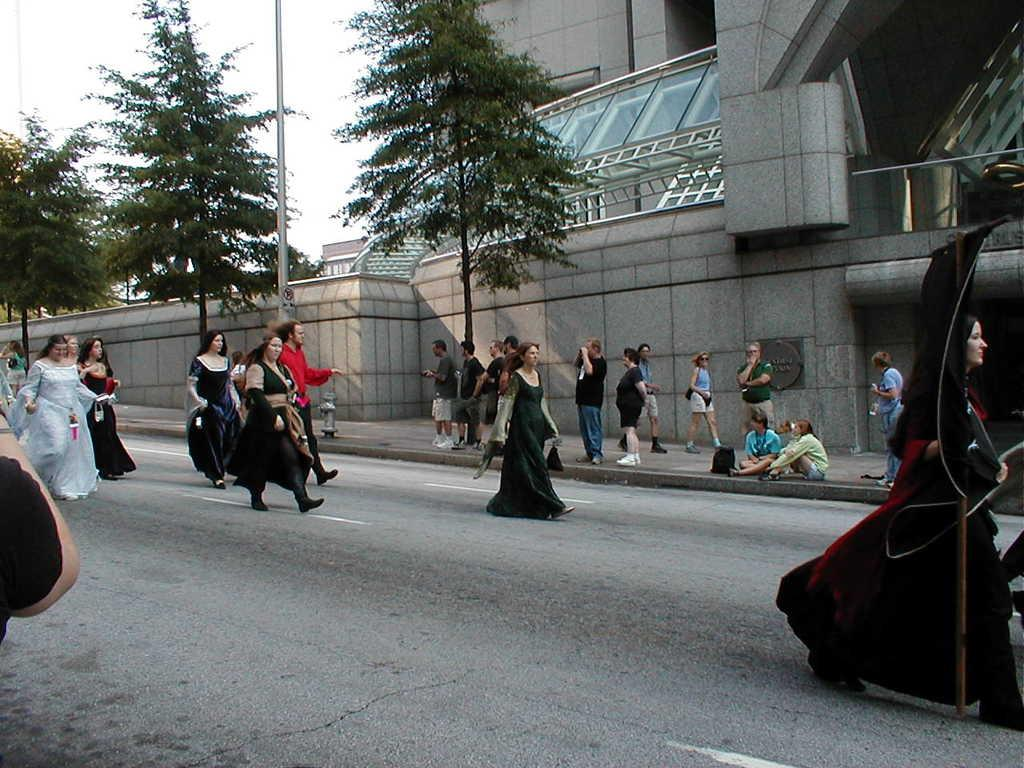How many people are in the image? There are people in the image, but the exact number is not specified. What are some of the people doing in the image? Some people are walking on the road in the image. What structures can be seen in the image? There are buildings, a pole, trees, and a wall visible in the image. What is visible in the background of the image? The sky is visible in the background of the image. What type of plantation can be seen in the image? There is no plantation present in the image; it features people walking on the road, buildings, a pole, trees, a wall, and the sky in the background. 